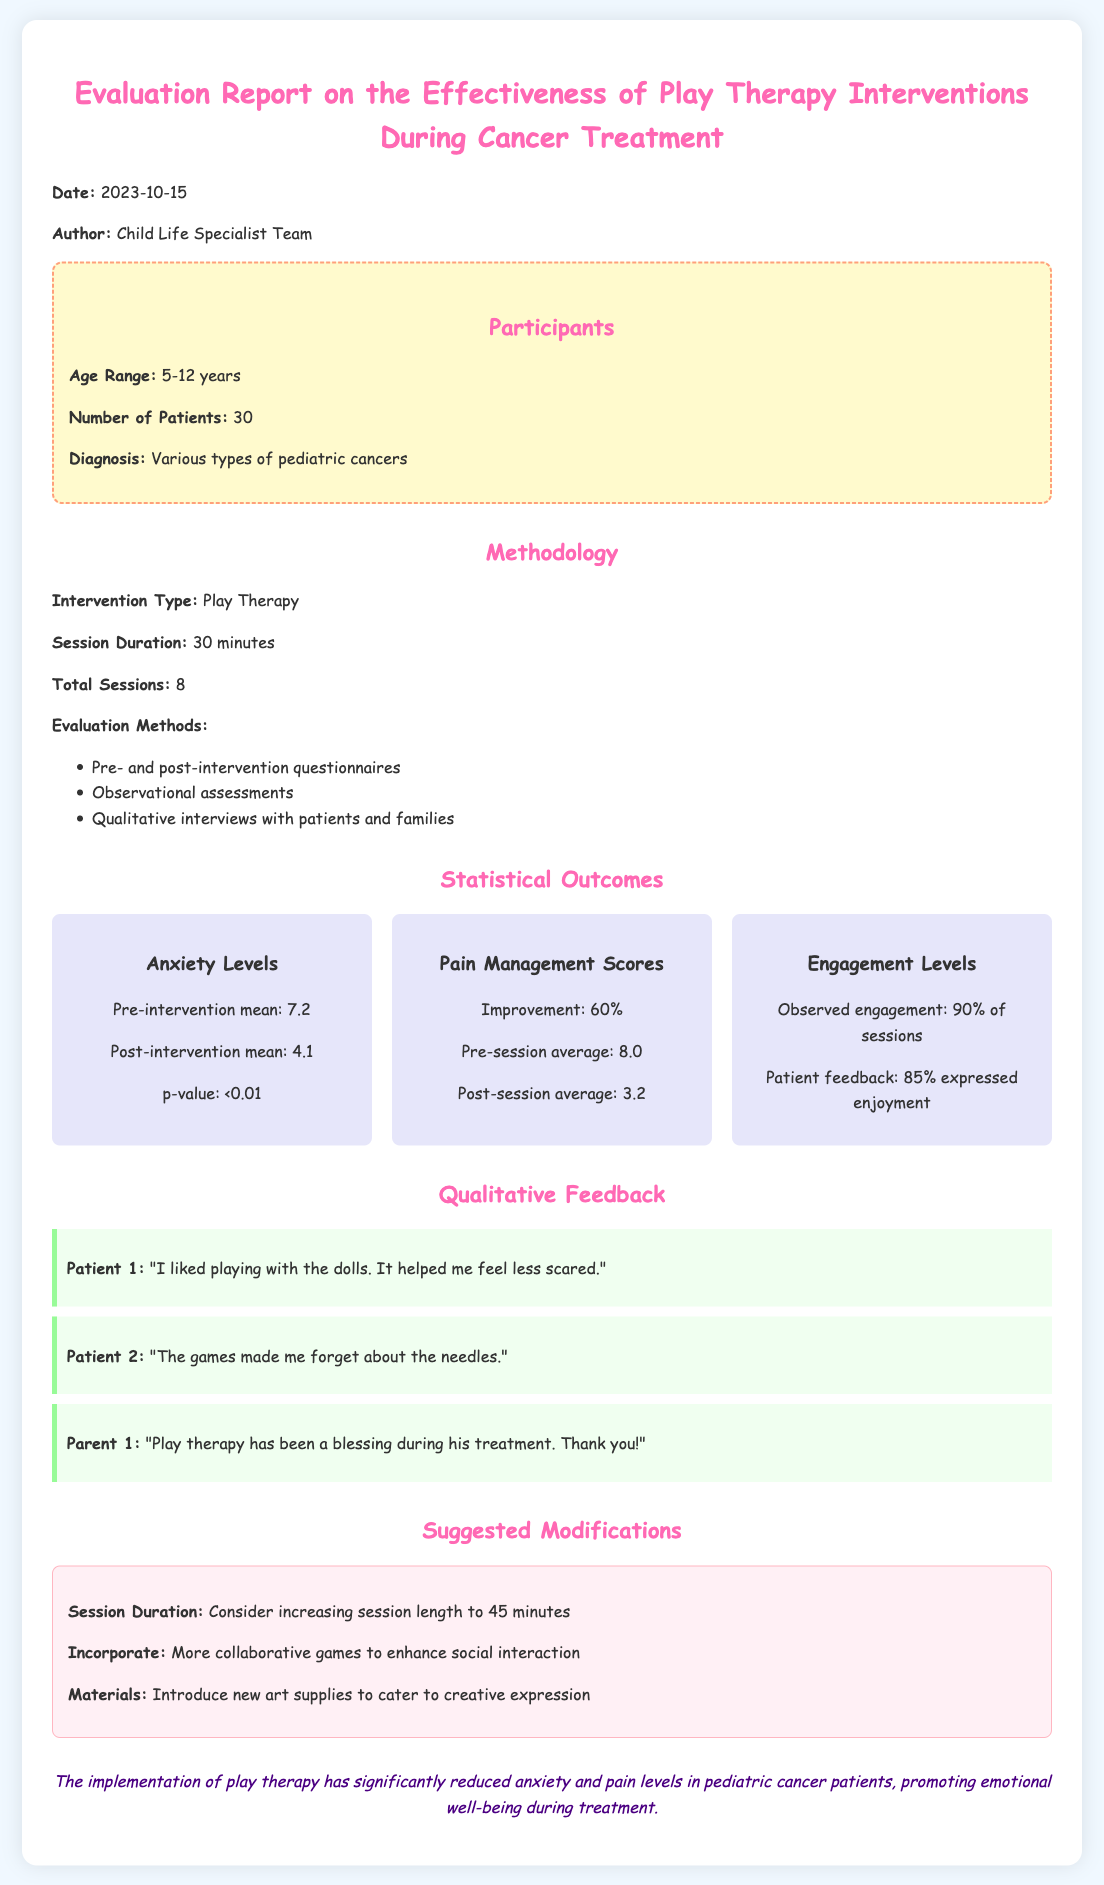What is the date of the report? The date of the report is mentioned at the beginning of the document, which is 2023-10-15.
Answer: 2023-10-15 How many patients participated in the evaluation? The number of patients is listed under the Participants section of the document, which states there were 30 patients.
Answer: 30 What was the pre-intervention mean anxiety level? The pre-intervention mean is provided in the Statistical Outcomes section, indicating it was 7.2.
Answer: 7.2 What percentage of patients expressed enjoyment during the sessions? This information can be found in the Engagement Levels statistical outcome, which states that 85% expressed enjoyment.
Answer: 85% What is one suggested modification for future sessions? The Suggested Modifications section lists modifications such as increasing session length to 45 minutes.
Answer: Increase session length to 45 minutes What was the improvement percentage in pain management scores? The document includes an improvement percentage in the Pain Management Scores section, which is 60%.
Answer: 60% Which type of cancer patients were involved in the report? The diagnosis details are included in the Participants section, which states various types of pediatric cancers.
Answer: Various types of pediatric cancers What is the observed engagement level during the sessions? This information can be found in the Engagement Levels section of the Statistical Outcomes, where it mentions 90% of sessions.
Answer: 90% of sessions 